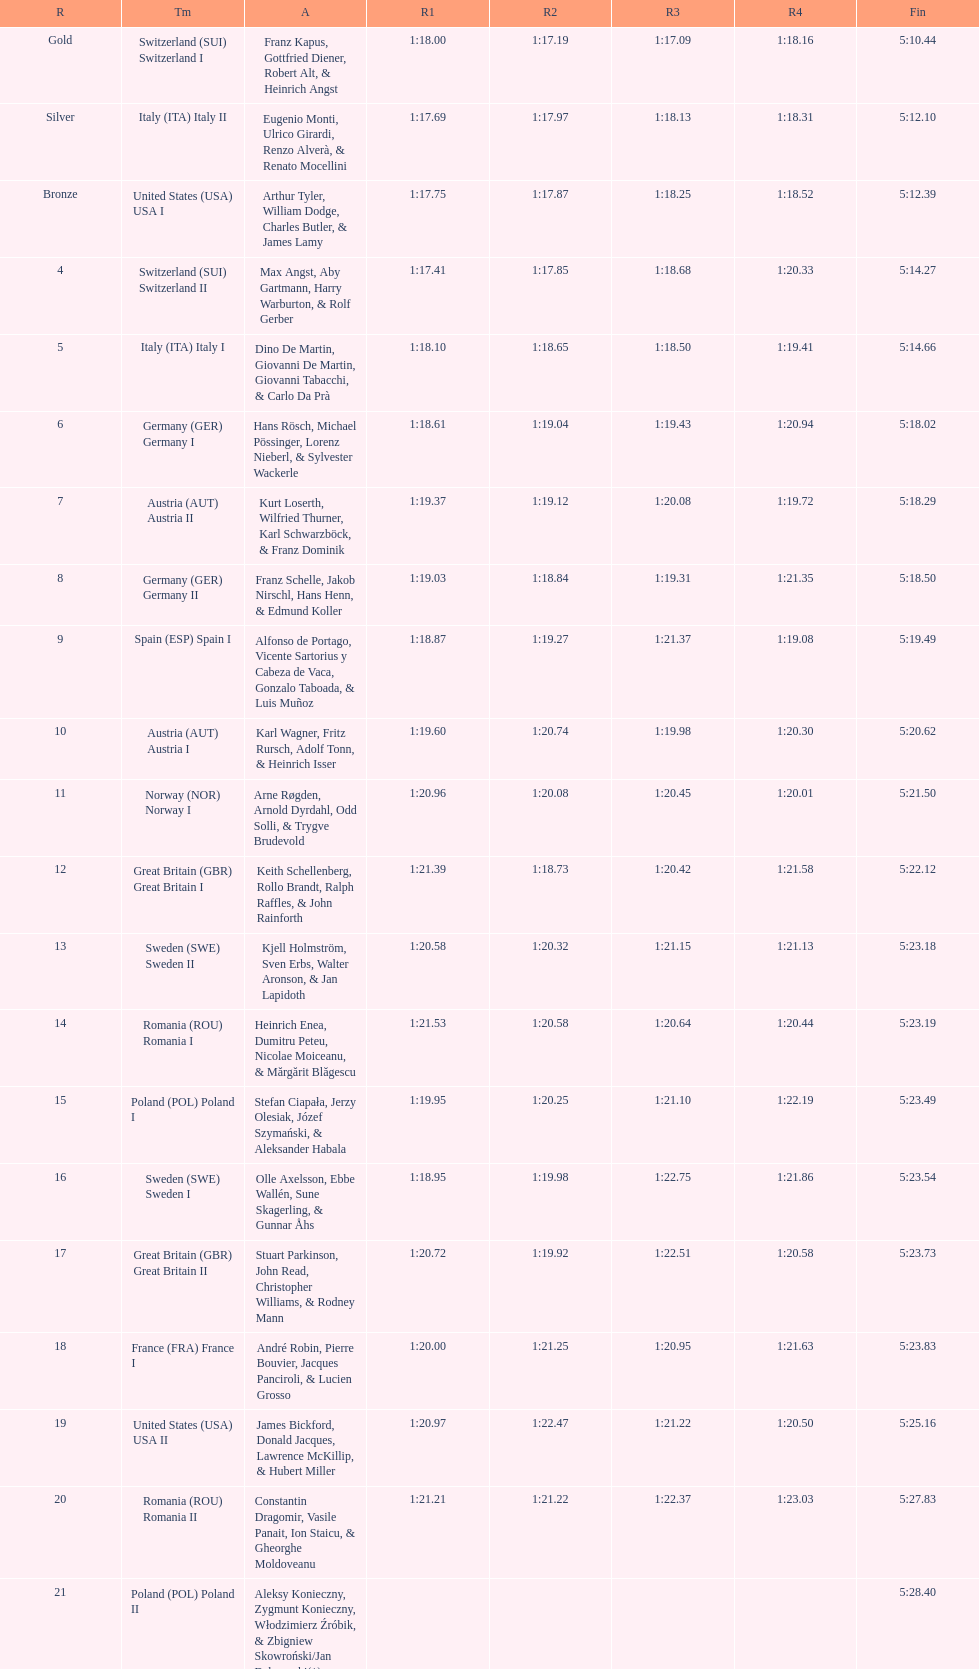Which team accumulated the greatest amount of runs? Switzerland. 